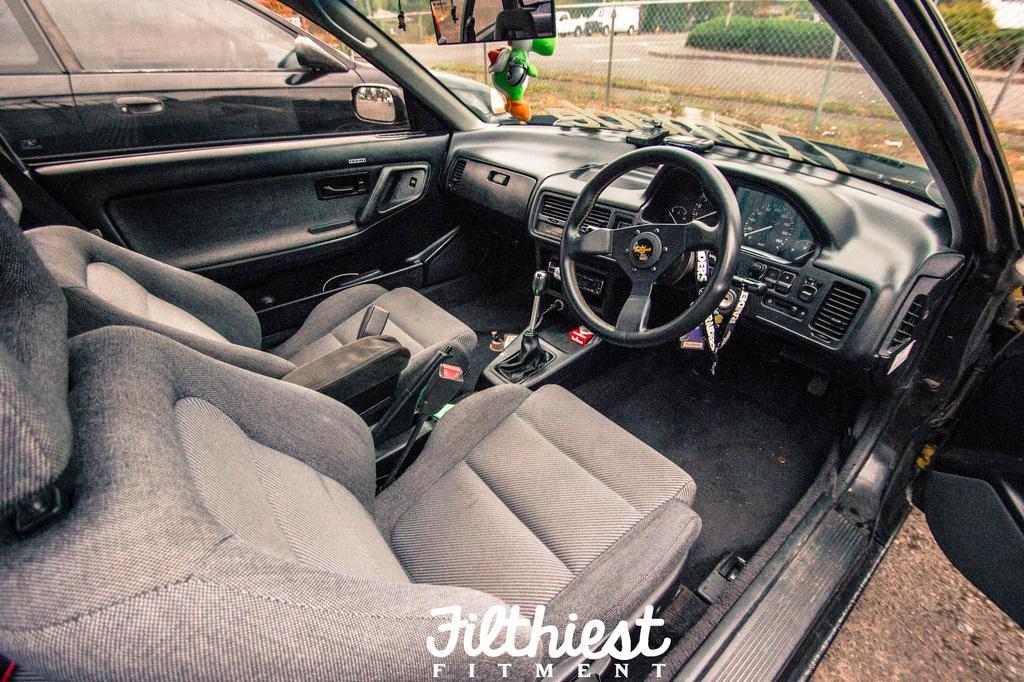Can you describe this image briefly? In this image I can see the interior of the car in which I can see two seats, the gear rod, the steering, the dashboard, the window and the windshield. I can see few vehicles, the road, few plants and the metal fencing in the background. 